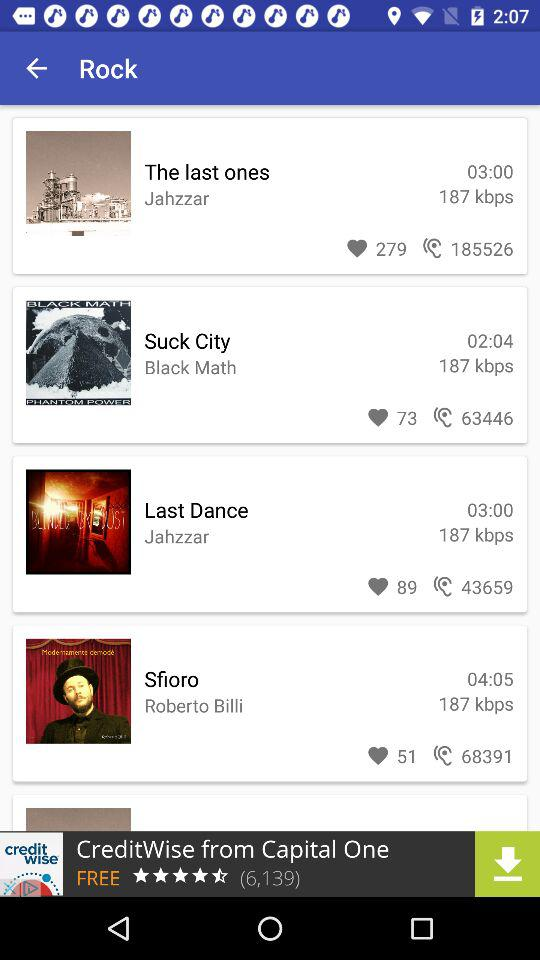Which artist has the most songs?
Answer the question using a single word or phrase. Jahzzar 